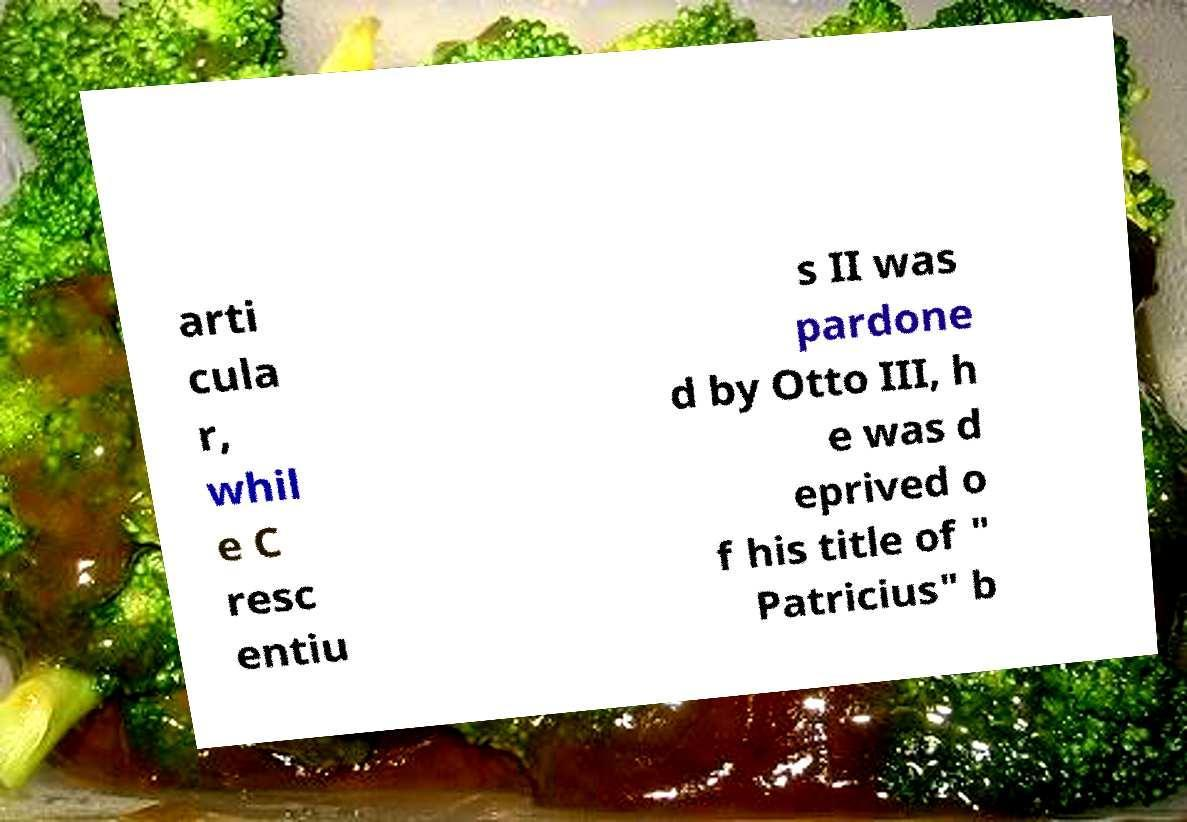What messages or text are displayed in this image? I need them in a readable, typed format. arti cula r, whil e C resc entiu s II was pardone d by Otto III, h e was d eprived o f his title of " Patricius" b 